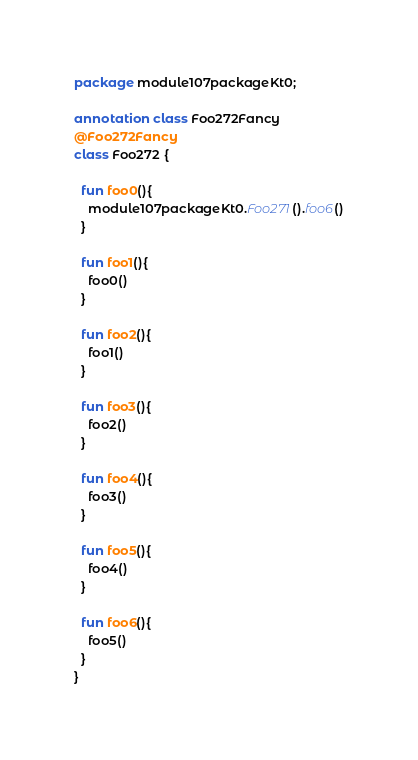Convert code to text. <code><loc_0><loc_0><loc_500><loc_500><_Kotlin_>package module107packageKt0;

annotation class Foo272Fancy
@Foo272Fancy
class Foo272 {

  fun foo0(){
    module107packageKt0.Foo271().foo6()
  }

  fun foo1(){
    foo0()
  }

  fun foo2(){
    foo1()
  }

  fun foo3(){
    foo2()
  }

  fun foo4(){
    foo3()
  }

  fun foo5(){
    foo4()
  }

  fun foo6(){
    foo5()
  }
}</code> 